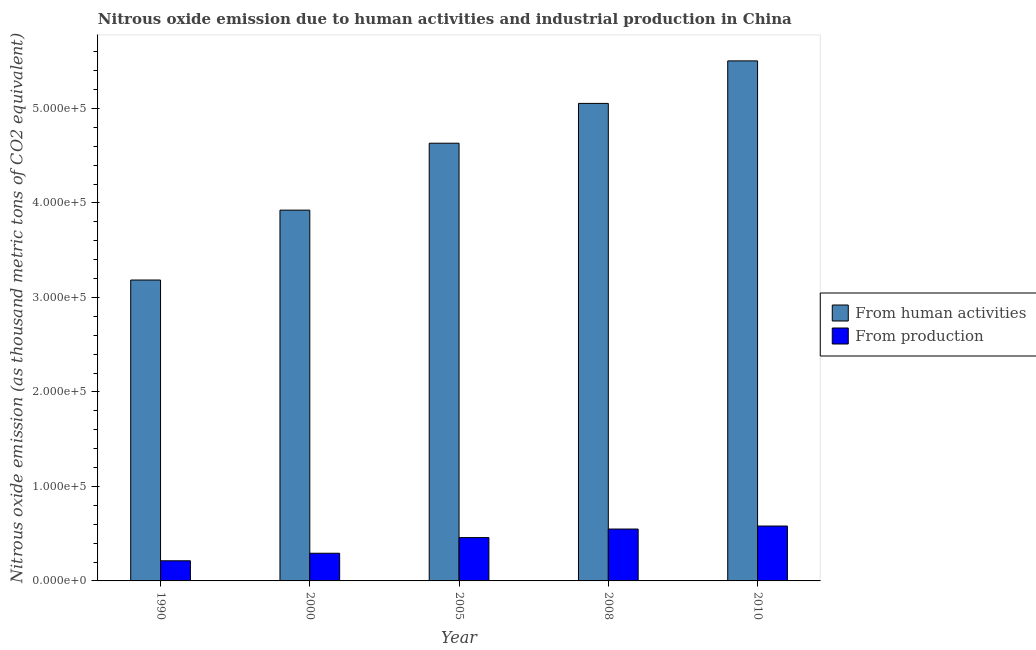How many different coloured bars are there?
Your answer should be compact. 2. Are the number of bars per tick equal to the number of legend labels?
Make the answer very short. Yes. Are the number of bars on each tick of the X-axis equal?
Your answer should be compact. Yes. How many bars are there on the 2nd tick from the right?
Make the answer very short. 2. What is the amount of emissions generated from industries in 2000?
Make the answer very short. 2.93e+04. Across all years, what is the maximum amount of emissions generated from industries?
Offer a terse response. 5.81e+04. Across all years, what is the minimum amount of emissions from human activities?
Your response must be concise. 3.18e+05. What is the total amount of emissions from human activities in the graph?
Provide a succinct answer. 2.23e+06. What is the difference between the amount of emissions from human activities in 1990 and that in 2005?
Give a very brief answer. -1.45e+05. What is the difference between the amount of emissions from human activities in 2000 and the amount of emissions generated from industries in 2010?
Your answer should be compact. -1.58e+05. What is the average amount of emissions from human activities per year?
Make the answer very short. 4.46e+05. What is the ratio of the amount of emissions from human activities in 1990 to that in 2010?
Your answer should be very brief. 0.58. What is the difference between the highest and the second highest amount of emissions from human activities?
Your answer should be compact. 4.50e+04. What is the difference between the highest and the lowest amount of emissions generated from industries?
Provide a short and direct response. 3.68e+04. What does the 2nd bar from the left in 2000 represents?
Provide a succinct answer. From production. What does the 2nd bar from the right in 2010 represents?
Give a very brief answer. From human activities. Are all the bars in the graph horizontal?
Ensure brevity in your answer.  No. How many years are there in the graph?
Offer a very short reply. 5. Are the values on the major ticks of Y-axis written in scientific E-notation?
Offer a terse response. Yes. Does the graph contain any zero values?
Provide a short and direct response. No. Does the graph contain grids?
Keep it short and to the point. No. How are the legend labels stacked?
Your answer should be very brief. Vertical. What is the title of the graph?
Your answer should be compact. Nitrous oxide emission due to human activities and industrial production in China. Does "Arms imports" appear as one of the legend labels in the graph?
Your answer should be very brief. No. What is the label or title of the Y-axis?
Keep it short and to the point. Nitrous oxide emission (as thousand metric tons of CO2 equivalent). What is the Nitrous oxide emission (as thousand metric tons of CO2 equivalent) of From human activities in 1990?
Your answer should be very brief. 3.18e+05. What is the Nitrous oxide emission (as thousand metric tons of CO2 equivalent) in From production in 1990?
Ensure brevity in your answer.  2.13e+04. What is the Nitrous oxide emission (as thousand metric tons of CO2 equivalent) in From human activities in 2000?
Provide a short and direct response. 3.92e+05. What is the Nitrous oxide emission (as thousand metric tons of CO2 equivalent) in From production in 2000?
Offer a very short reply. 2.93e+04. What is the Nitrous oxide emission (as thousand metric tons of CO2 equivalent) in From human activities in 2005?
Ensure brevity in your answer.  4.63e+05. What is the Nitrous oxide emission (as thousand metric tons of CO2 equivalent) of From production in 2005?
Make the answer very short. 4.58e+04. What is the Nitrous oxide emission (as thousand metric tons of CO2 equivalent) in From human activities in 2008?
Provide a succinct answer. 5.05e+05. What is the Nitrous oxide emission (as thousand metric tons of CO2 equivalent) in From production in 2008?
Your answer should be compact. 5.49e+04. What is the Nitrous oxide emission (as thousand metric tons of CO2 equivalent) in From human activities in 2010?
Offer a very short reply. 5.50e+05. What is the Nitrous oxide emission (as thousand metric tons of CO2 equivalent) in From production in 2010?
Provide a short and direct response. 5.81e+04. Across all years, what is the maximum Nitrous oxide emission (as thousand metric tons of CO2 equivalent) in From human activities?
Your answer should be compact. 5.50e+05. Across all years, what is the maximum Nitrous oxide emission (as thousand metric tons of CO2 equivalent) in From production?
Offer a very short reply. 5.81e+04. Across all years, what is the minimum Nitrous oxide emission (as thousand metric tons of CO2 equivalent) in From human activities?
Ensure brevity in your answer.  3.18e+05. Across all years, what is the minimum Nitrous oxide emission (as thousand metric tons of CO2 equivalent) of From production?
Give a very brief answer. 2.13e+04. What is the total Nitrous oxide emission (as thousand metric tons of CO2 equivalent) of From human activities in the graph?
Make the answer very short. 2.23e+06. What is the total Nitrous oxide emission (as thousand metric tons of CO2 equivalent) of From production in the graph?
Keep it short and to the point. 2.09e+05. What is the difference between the Nitrous oxide emission (as thousand metric tons of CO2 equivalent) of From human activities in 1990 and that in 2000?
Provide a succinct answer. -7.40e+04. What is the difference between the Nitrous oxide emission (as thousand metric tons of CO2 equivalent) of From production in 1990 and that in 2000?
Make the answer very short. -7984.9. What is the difference between the Nitrous oxide emission (as thousand metric tons of CO2 equivalent) in From human activities in 1990 and that in 2005?
Offer a very short reply. -1.45e+05. What is the difference between the Nitrous oxide emission (as thousand metric tons of CO2 equivalent) of From production in 1990 and that in 2005?
Provide a succinct answer. -2.45e+04. What is the difference between the Nitrous oxide emission (as thousand metric tons of CO2 equivalent) in From human activities in 1990 and that in 2008?
Your answer should be very brief. -1.87e+05. What is the difference between the Nitrous oxide emission (as thousand metric tons of CO2 equivalent) of From production in 1990 and that in 2008?
Provide a short and direct response. -3.36e+04. What is the difference between the Nitrous oxide emission (as thousand metric tons of CO2 equivalent) in From human activities in 1990 and that in 2010?
Provide a succinct answer. -2.32e+05. What is the difference between the Nitrous oxide emission (as thousand metric tons of CO2 equivalent) in From production in 1990 and that in 2010?
Provide a succinct answer. -3.68e+04. What is the difference between the Nitrous oxide emission (as thousand metric tons of CO2 equivalent) of From human activities in 2000 and that in 2005?
Your answer should be very brief. -7.08e+04. What is the difference between the Nitrous oxide emission (as thousand metric tons of CO2 equivalent) in From production in 2000 and that in 2005?
Make the answer very short. -1.66e+04. What is the difference between the Nitrous oxide emission (as thousand metric tons of CO2 equivalent) in From human activities in 2000 and that in 2008?
Provide a succinct answer. -1.13e+05. What is the difference between the Nitrous oxide emission (as thousand metric tons of CO2 equivalent) of From production in 2000 and that in 2008?
Make the answer very short. -2.56e+04. What is the difference between the Nitrous oxide emission (as thousand metric tons of CO2 equivalent) of From human activities in 2000 and that in 2010?
Offer a terse response. -1.58e+05. What is the difference between the Nitrous oxide emission (as thousand metric tons of CO2 equivalent) in From production in 2000 and that in 2010?
Provide a short and direct response. -2.88e+04. What is the difference between the Nitrous oxide emission (as thousand metric tons of CO2 equivalent) in From human activities in 2005 and that in 2008?
Offer a very short reply. -4.21e+04. What is the difference between the Nitrous oxide emission (as thousand metric tons of CO2 equivalent) of From production in 2005 and that in 2008?
Your response must be concise. -9056.8. What is the difference between the Nitrous oxide emission (as thousand metric tons of CO2 equivalent) of From human activities in 2005 and that in 2010?
Give a very brief answer. -8.71e+04. What is the difference between the Nitrous oxide emission (as thousand metric tons of CO2 equivalent) of From production in 2005 and that in 2010?
Make the answer very short. -1.22e+04. What is the difference between the Nitrous oxide emission (as thousand metric tons of CO2 equivalent) in From human activities in 2008 and that in 2010?
Offer a terse response. -4.50e+04. What is the difference between the Nitrous oxide emission (as thousand metric tons of CO2 equivalent) of From production in 2008 and that in 2010?
Offer a very short reply. -3175.5. What is the difference between the Nitrous oxide emission (as thousand metric tons of CO2 equivalent) of From human activities in 1990 and the Nitrous oxide emission (as thousand metric tons of CO2 equivalent) of From production in 2000?
Make the answer very short. 2.89e+05. What is the difference between the Nitrous oxide emission (as thousand metric tons of CO2 equivalent) of From human activities in 1990 and the Nitrous oxide emission (as thousand metric tons of CO2 equivalent) of From production in 2005?
Ensure brevity in your answer.  2.73e+05. What is the difference between the Nitrous oxide emission (as thousand metric tons of CO2 equivalent) of From human activities in 1990 and the Nitrous oxide emission (as thousand metric tons of CO2 equivalent) of From production in 2008?
Your answer should be compact. 2.64e+05. What is the difference between the Nitrous oxide emission (as thousand metric tons of CO2 equivalent) of From human activities in 1990 and the Nitrous oxide emission (as thousand metric tons of CO2 equivalent) of From production in 2010?
Provide a succinct answer. 2.60e+05. What is the difference between the Nitrous oxide emission (as thousand metric tons of CO2 equivalent) of From human activities in 2000 and the Nitrous oxide emission (as thousand metric tons of CO2 equivalent) of From production in 2005?
Your answer should be compact. 3.47e+05. What is the difference between the Nitrous oxide emission (as thousand metric tons of CO2 equivalent) in From human activities in 2000 and the Nitrous oxide emission (as thousand metric tons of CO2 equivalent) in From production in 2008?
Provide a succinct answer. 3.37e+05. What is the difference between the Nitrous oxide emission (as thousand metric tons of CO2 equivalent) of From human activities in 2000 and the Nitrous oxide emission (as thousand metric tons of CO2 equivalent) of From production in 2010?
Ensure brevity in your answer.  3.34e+05. What is the difference between the Nitrous oxide emission (as thousand metric tons of CO2 equivalent) of From human activities in 2005 and the Nitrous oxide emission (as thousand metric tons of CO2 equivalent) of From production in 2008?
Keep it short and to the point. 4.08e+05. What is the difference between the Nitrous oxide emission (as thousand metric tons of CO2 equivalent) of From human activities in 2005 and the Nitrous oxide emission (as thousand metric tons of CO2 equivalent) of From production in 2010?
Provide a succinct answer. 4.05e+05. What is the difference between the Nitrous oxide emission (as thousand metric tons of CO2 equivalent) in From human activities in 2008 and the Nitrous oxide emission (as thousand metric tons of CO2 equivalent) in From production in 2010?
Keep it short and to the point. 4.47e+05. What is the average Nitrous oxide emission (as thousand metric tons of CO2 equivalent) of From human activities per year?
Provide a succinct answer. 4.46e+05. What is the average Nitrous oxide emission (as thousand metric tons of CO2 equivalent) of From production per year?
Make the answer very short. 4.19e+04. In the year 1990, what is the difference between the Nitrous oxide emission (as thousand metric tons of CO2 equivalent) of From human activities and Nitrous oxide emission (as thousand metric tons of CO2 equivalent) of From production?
Offer a terse response. 2.97e+05. In the year 2000, what is the difference between the Nitrous oxide emission (as thousand metric tons of CO2 equivalent) of From human activities and Nitrous oxide emission (as thousand metric tons of CO2 equivalent) of From production?
Make the answer very short. 3.63e+05. In the year 2005, what is the difference between the Nitrous oxide emission (as thousand metric tons of CO2 equivalent) of From human activities and Nitrous oxide emission (as thousand metric tons of CO2 equivalent) of From production?
Your answer should be compact. 4.17e+05. In the year 2008, what is the difference between the Nitrous oxide emission (as thousand metric tons of CO2 equivalent) in From human activities and Nitrous oxide emission (as thousand metric tons of CO2 equivalent) in From production?
Ensure brevity in your answer.  4.50e+05. In the year 2010, what is the difference between the Nitrous oxide emission (as thousand metric tons of CO2 equivalent) in From human activities and Nitrous oxide emission (as thousand metric tons of CO2 equivalent) in From production?
Your answer should be compact. 4.92e+05. What is the ratio of the Nitrous oxide emission (as thousand metric tons of CO2 equivalent) of From human activities in 1990 to that in 2000?
Provide a succinct answer. 0.81. What is the ratio of the Nitrous oxide emission (as thousand metric tons of CO2 equivalent) in From production in 1990 to that in 2000?
Provide a succinct answer. 0.73. What is the ratio of the Nitrous oxide emission (as thousand metric tons of CO2 equivalent) in From human activities in 1990 to that in 2005?
Ensure brevity in your answer.  0.69. What is the ratio of the Nitrous oxide emission (as thousand metric tons of CO2 equivalent) of From production in 1990 to that in 2005?
Offer a terse response. 0.46. What is the ratio of the Nitrous oxide emission (as thousand metric tons of CO2 equivalent) in From human activities in 1990 to that in 2008?
Give a very brief answer. 0.63. What is the ratio of the Nitrous oxide emission (as thousand metric tons of CO2 equivalent) of From production in 1990 to that in 2008?
Make the answer very short. 0.39. What is the ratio of the Nitrous oxide emission (as thousand metric tons of CO2 equivalent) of From human activities in 1990 to that in 2010?
Provide a short and direct response. 0.58. What is the ratio of the Nitrous oxide emission (as thousand metric tons of CO2 equivalent) in From production in 1990 to that in 2010?
Provide a succinct answer. 0.37. What is the ratio of the Nitrous oxide emission (as thousand metric tons of CO2 equivalent) in From human activities in 2000 to that in 2005?
Your response must be concise. 0.85. What is the ratio of the Nitrous oxide emission (as thousand metric tons of CO2 equivalent) of From production in 2000 to that in 2005?
Your response must be concise. 0.64. What is the ratio of the Nitrous oxide emission (as thousand metric tons of CO2 equivalent) of From human activities in 2000 to that in 2008?
Ensure brevity in your answer.  0.78. What is the ratio of the Nitrous oxide emission (as thousand metric tons of CO2 equivalent) of From production in 2000 to that in 2008?
Your response must be concise. 0.53. What is the ratio of the Nitrous oxide emission (as thousand metric tons of CO2 equivalent) of From human activities in 2000 to that in 2010?
Make the answer very short. 0.71. What is the ratio of the Nitrous oxide emission (as thousand metric tons of CO2 equivalent) in From production in 2000 to that in 2010?
Keep it short and to the point. 0.5. What is the ratio of the Nitrous oxide emission (as thousand metric tons of CO2 equivalent) of From human activities in 2005 to that in 2008?
Offer a very short reply. 0.92. What is the ratio of the Nitrous oxide emission (as thousand metric tons of CO2 equivalent) in From production in 2005 to that in 2008?
Keep it short and to the point. 0.83. What is the ratio of the Nitrous oxide emission (as thousand metric tons of CO2 equivalent) of From human activities in 2005 to that in 2010?
Provide a succinct answer. 0.84. What is the ratio of the Nitrous oxide emission (as thousand metric tons of CO2 equivalent) of From production in 2005 to that in 2010?
Your answer should be very brief. 0.79. What is the ratio of the Nitrous oxide emission (as thousand metric tons of CO2 equivalent) in From human activities in 2008 to that in 2010?
Provide a short and direct response. 0.92. What is the ratio of the Nitrous oxide emission (as thousand metric tons of CO2 equivalent) in From production in 2008 to that in 2010?
Your answer should be compact. 0.95. What is the difference between the highest and the second highest Nitrous oxide emission (as thousand metric tons of CO2 equivalent) in From human activities?
Your response must be concise. 4.50e+04. What is the difference between the highest and the second highest Nitrous oxide emission (as thousand metric tons of CO2 equivalent) in From production?
Offer a very short reply. 3175.5. What is the difference between the highest and the lowest Nitrous oxide emission (as thousand metric tons of CO2 equivalent) in From human activities?
Make the answer very short. 2.32e+05. What is the difference between the highest and the lowest Nitrous oxide emission (as thousand metric tons of CO2 equivalent) of From production?
Offer a very short reply. 3.68e+04. 